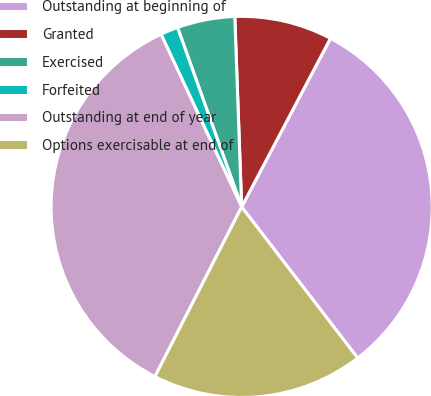Convert chart to OTSL. <chart><loc_0><loc_0><loc_500><loc_500><pie_chart><fcel>Outstanding at beginning of<fcel>Granted<fcel>Exercised<fcel>Forfeited<fcel>Outstanding at end of year<fcel>Options exercisable at end of<nl><fcel>31.86%<fcel>8.29%<fcel>4.89%<fcel>1.49%<fcel>35.53%<fcel>17.94%<nl></chart> 